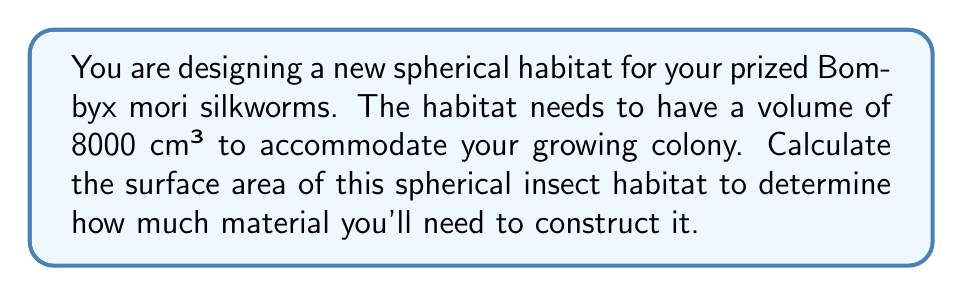Help me with this question. To solve this problem, we'll follow these steps:

1) First, recall the formulas for the volume and surface area of a sphere:
   Volume: $V = \frac{4}{3}\pi r^3$
   Surface Area: $A = 4\pi r^2$

   Where $r$ is the radius of the sphere.

2) We're given the volume, so let's start by finding the radius:

   $8000 = \frac{4}{3}\pi r^3$

3) Solve for $r$:
   
   $r^3 = \frac{8000 \cdot 3}{4\pi}$
   
   $r = \sqrt[3]{\frac{8000 \cdot 3}{4\pi}} \approx 12.4 \text{ cm}$

4) Now that we have the radius, we can calculate the surface area:

   $A = 4\pi r^2$
   
   $A = 4\pi (12.4)^2$
   
   $A \approx 1931 \text{ cm}^2$

Therefore, the surface area of the spherical insect habitat is approximately 1931 cm².
Answer: $A \approx 1931 \text{ cm}^2$ 